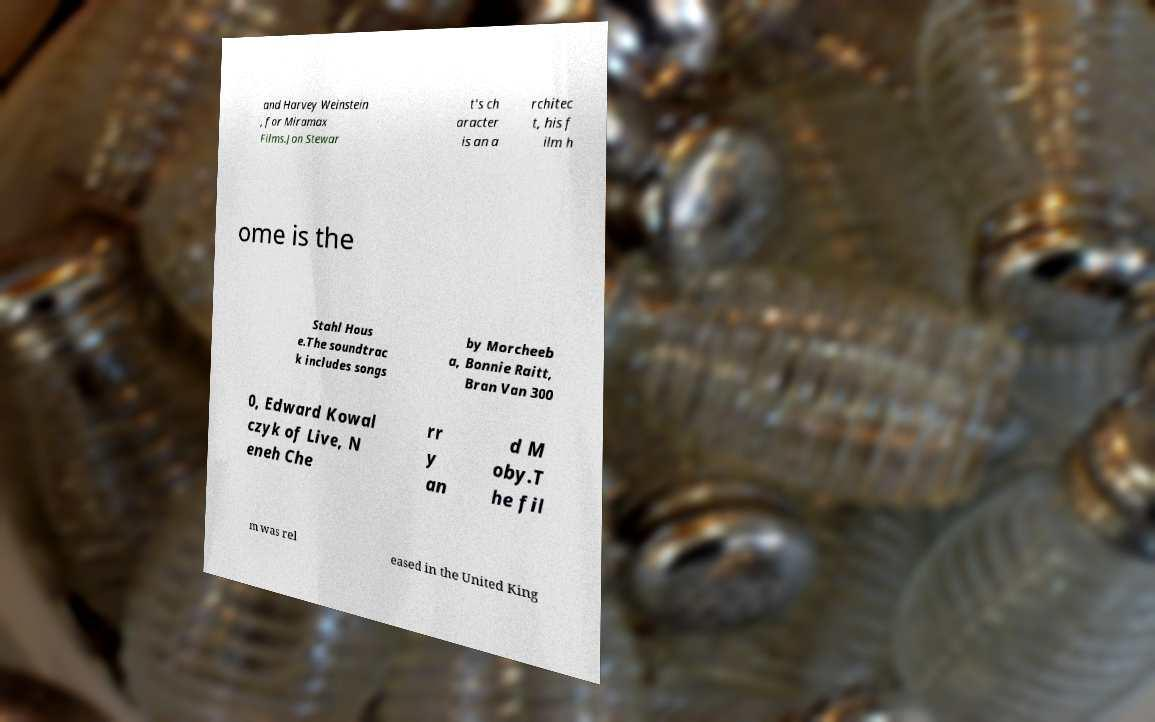I need the written content from this picture converted into text. Can you do that? and Harvey Weinstein , for Miramax Films.Jon Stewar t's ch aracter is an a rchitec t, his f ilm h ome is the Stahl Hous e.The soundtrac k includes songs by Morcheeb a, Bonnie Raitt, Bran Van 300 0, Edward Kowal czyk of Live, N eneh Che rr y an d M oby.T he fil m was rel eased in the United King 